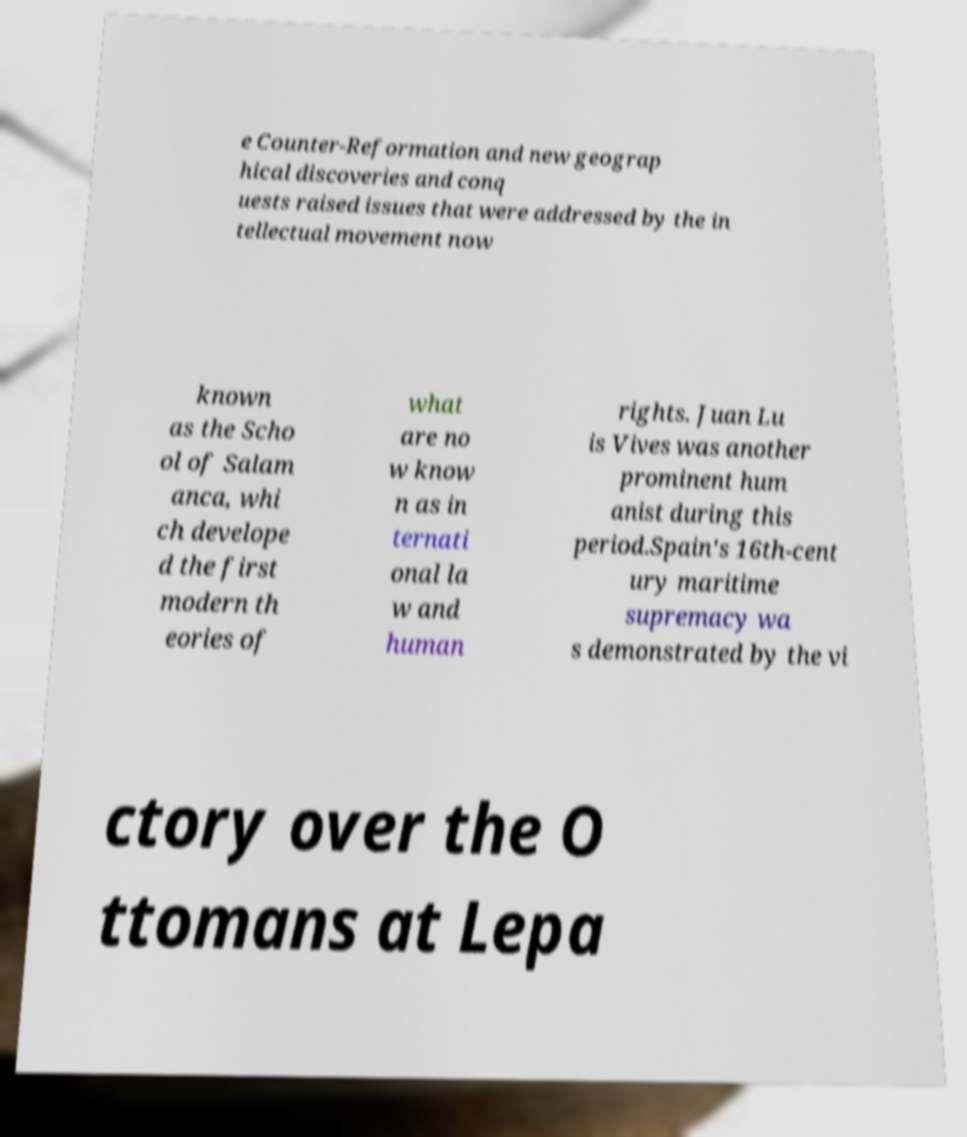Please identify and transcribe the text found in this image. e Counter-Reformation and new geograp hical discoveries and conq uests raised issues that were addressed by the in tellectual movement now known as the Scho ol of Salam anca, whi ch develope d the first modern th eories of what are no w know n as in ternati onal la w and human rights. Juan Lu is Vives was another prominent hum anist during this period.Spain's 16th-cent ury maritime supremacy wa s demonstrated by the vi ctory over the O ttomans at Lepa 